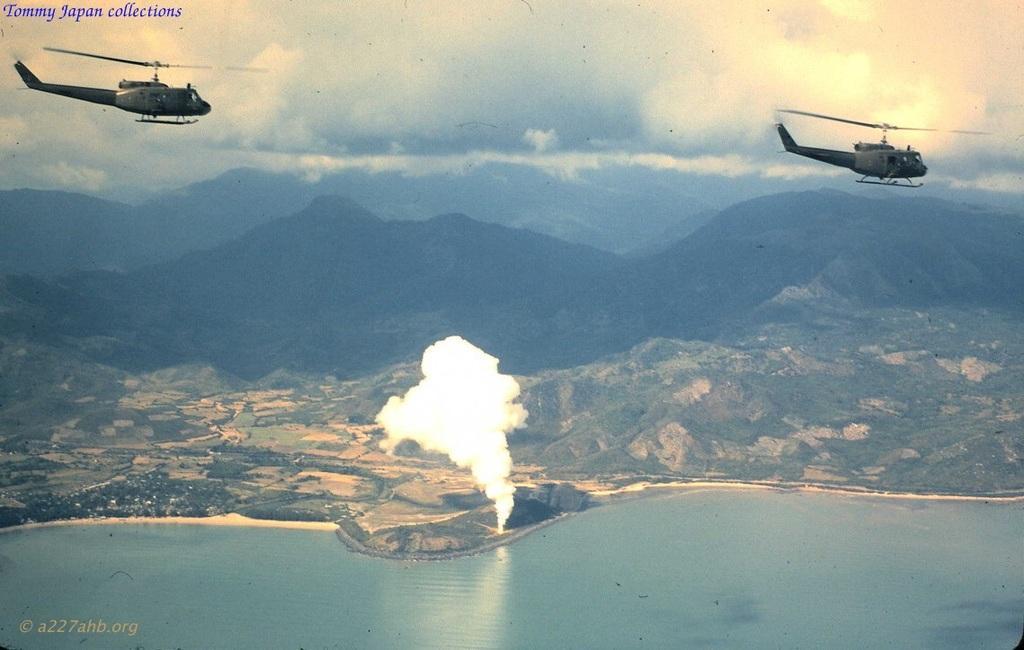How would you summarize this image in a sentence or two? This image is taken outdoors. At the bottom of the image there is a sea with water. At the top of the image there is the sky with clouds and two choppers are flying in the sky. In the background there are a few hills. In the middle of the image there are many trees, planted on the ground and there is a fire and smoke. 